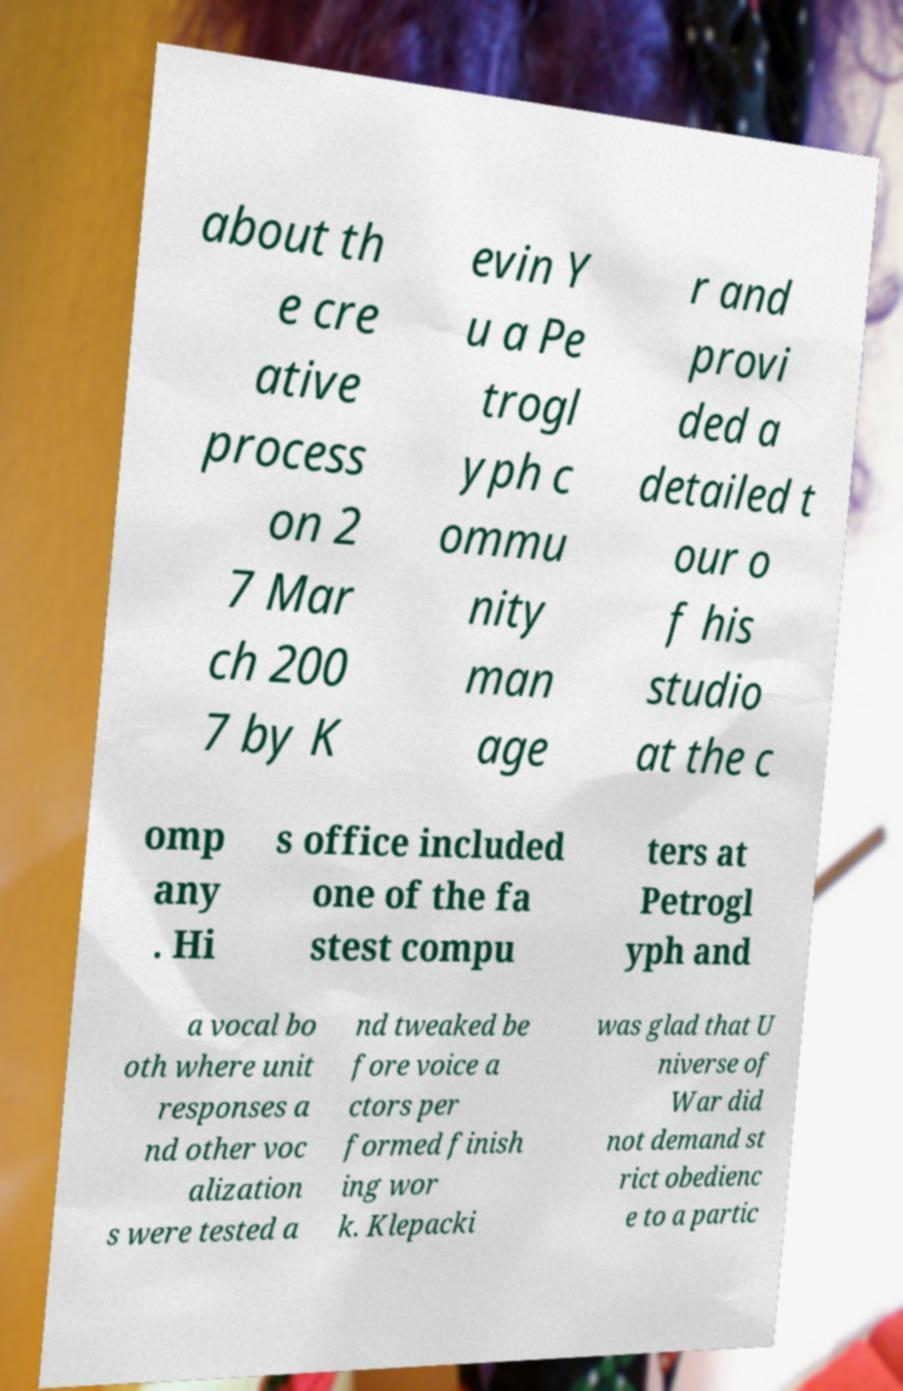Please identify and transcribe the text found in this image. about th e cre ative process on 2 7 Mar ch 200 7 by K evin Y u a Pe trogl yph c ommu nity man age r and provi ded a detailed t our o f his studio at the c omp any . Hi s office included one of the fa stest compu ters at Petrogl yph and a vocal bo oth where unit responses a nd other voc alization s were tested a nd tweaked be fore voice a ctors per formed finish ing wor k. Klepacki was glad that U niverse of War did not demand st rict obedienc e to a partic 